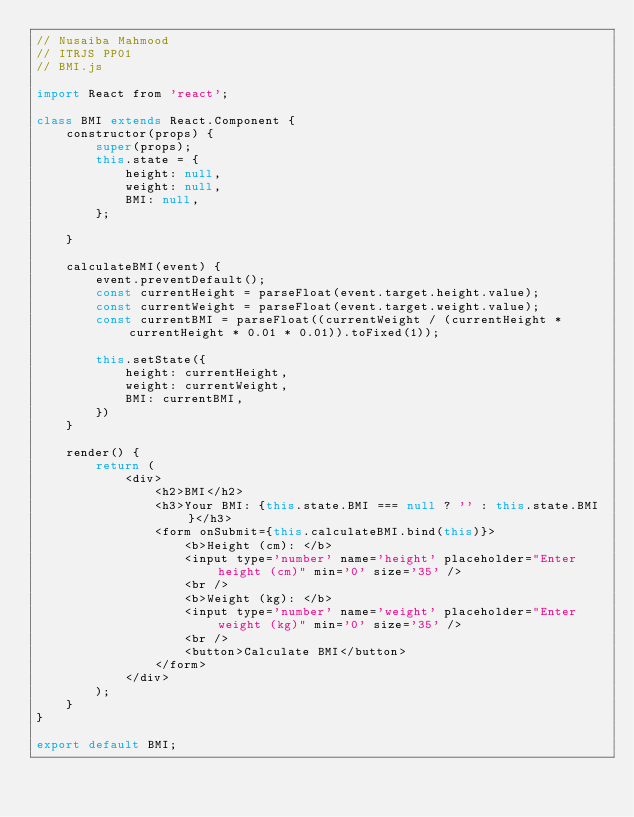Convert code to text. <code><loc_0><loc_0><loc_500><loc_500><_JavaScript_>// Nusaiba Mahmood
// ITRJS PP01
// BMI.js

import React from 'react';

class BMI extends React.Component {
    constructor(props) {
        super(props);
        this.state = {
            height: null,
            weight: null,
            BMI: null,
        };

    }

    calculateBMI(event) {
        event.preventDefault();
        const currentHeight = parseFloat(event.target.height.value);
        const currentWeight = parseFloat(event.target.weight.value);
        const currentBMI = parseFloat((currentWeight / (currentHeight * currentHeight * 0.01 * 0.01)).toFixed(1));

        this.setState({
            height: currentHeight,
            weight: currentWeight,
            BMI: currentBMI,
        })
    }

    render() {
        return (
            <div>
                <h2>BMI</h2>
                <h3>Your BMI: {this.state.BMI === null ? '' : this.state.BMI}</h3>
                <form onSubmit={this.calculateBMI.bind(this)}>
                    <b>Height (cm): </b>
                    <input type='number' name='height' placeholder="Enter height (cm)" min='0' size='35' />
                    <br />
                    <b>Weight (kg): </b>
                    <input type='number' name='weight' placeholder="Enter weight (kg)" min='0' size='35' />
                    <br />
                    <button>Calculate BMI</button>
                </form>
            </div>
        );
    }
}

export default BMI;
</code> 